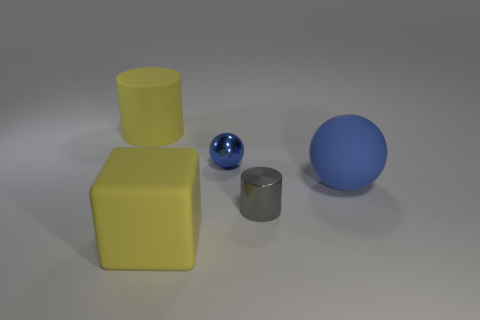There is a matte thing that is on the left side of the small blue shiny sphere and behind the big rubber cube; what size is it?
Make the answer very short. Large. Does the tiny ball have the same color as the rubber object that is right of the big yellow cube?
Keep it short and to the point. Yes. Are there any large yellow objects that have the same shape as the small gray metal object?
Give a very brief answer. Yes. How many objects are either spheres or big matte objects that are on the left side of the tiny gray cylinder?
Offer a terse response. 4. How many other objects are there of the same material as the large yellow cylinder?
Your answer should be very brief. 2. How many objects are small gray shiny cylinders or tiny red blocks?
Offer a very short reply. 1. Are there more tiny cylinders behind the tiny metal ball than big blue matte things that are right of the big blue rubber sphere?
Offer a very short reply. No. There is a big rubber block that is left of the blue rubber ball; is its color the same as the cylinder that is on the right side of the large yellow matte cube?
Make the answer very short. No. How big is the blue ball behind the ball right of the metallic cylinder right of the large yellow rubber cube?
Provide a short and direct response. Small. What is the color of the other large matte object that is the same shape as the gray thing?
Ensure brevity in your answer.  Yellow. 